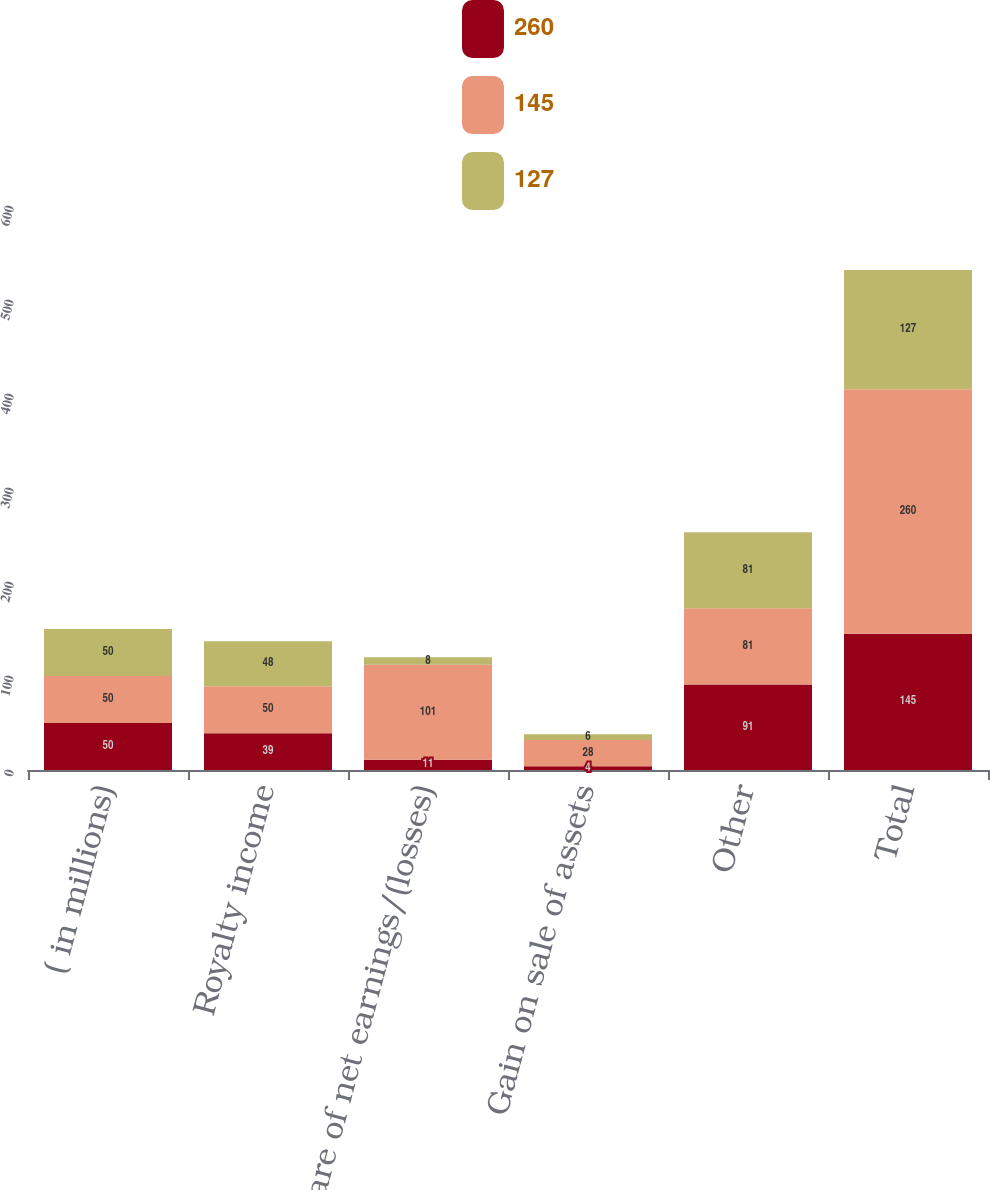Convert chart to OTSL. <chart><loc_0><loc_0><loc_500><loc_500><stacked_bar_chart><ecel><fcel>( in millions)<fcel>Royalty income<fcel>Share of net earnings/(losses)<fcel>Gain on sale of assets<fcel>Other<fcel>Total<nl><fcel>260<fcel>50<fcel>39<fcel>11<fcel>4<fcel>91<fcel>145<nl><fcel>145<fcel>50<fcel>50<fcel>101<fcel>28<fcel>81<fcel>260<nl><fcel>127<fcel>50<fcel>48<fcel>8<fcel>6<fcel>81<fcel>127<nl></chart> 